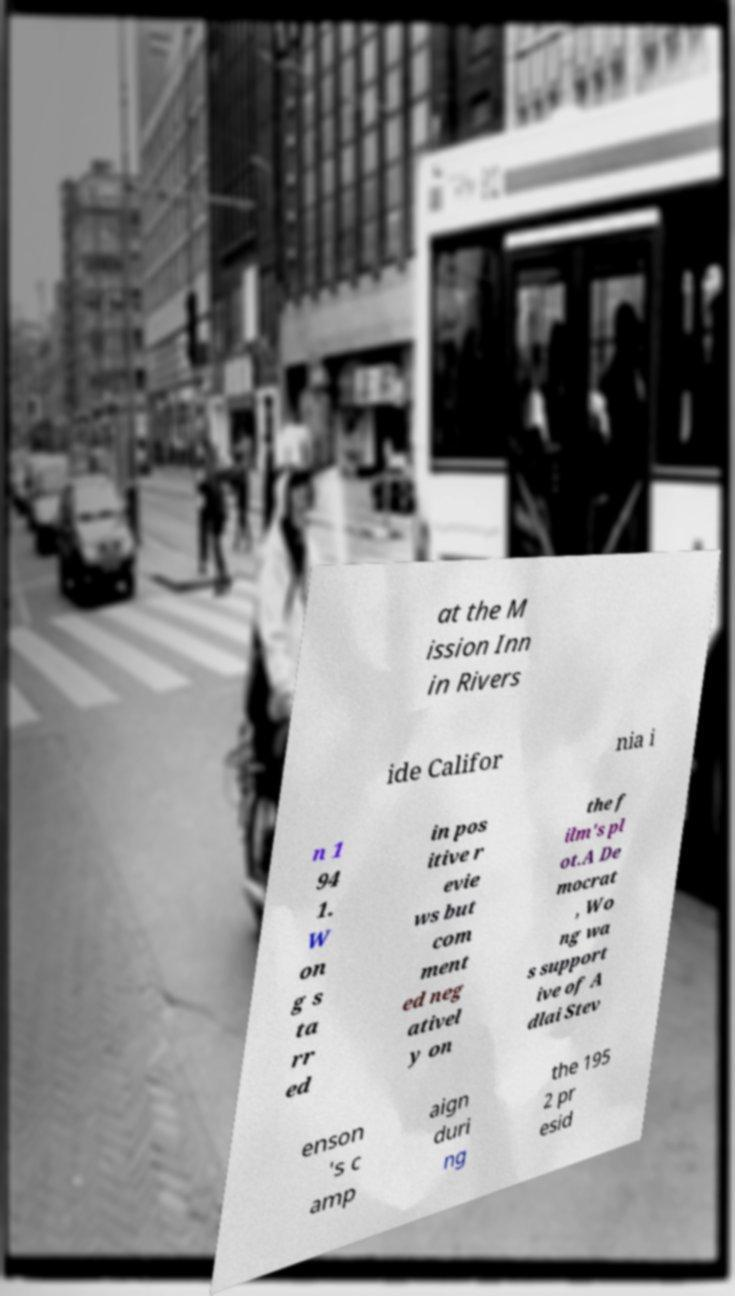What messages or text are displayed in this image? I need them in a readable, typed format. at the M ission Inn in Rivers ide Califor nia i n 1 94 1. W on g s ta rr ed in pos itive r evie ws but com ment ed neg ativel y on the f ilm's pl ot.A De mocrat , Wo ng wa s support ive of A dlai Stev enson 's c amp aign duri ng the 195 2 pr esid 